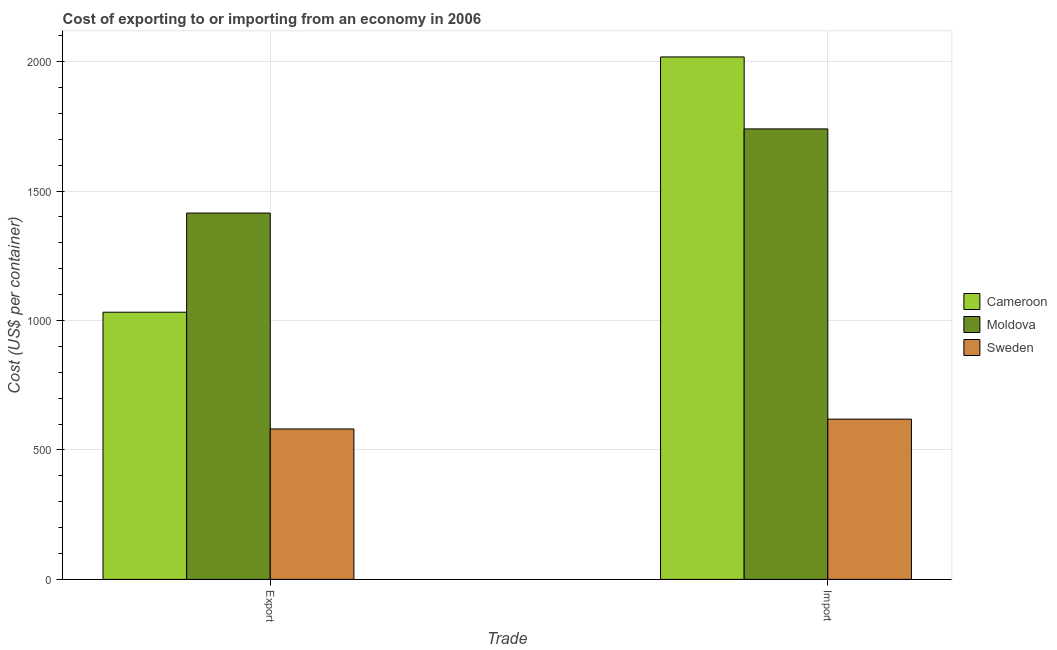How many groups of bars are there?
Offer a very short reply. 2. Are the number of bars on each tick of the X-axis equal?
Your answer should be very brief. Yes. How many bars are there on the 2nd tick from the right?
Your response must be concise. 3. What is the label of the 2nd group of bars from the left?
Provide a succinct answer. Import. What is the import cost in Sweden?
Make the answer very short. 619. Across all countries, what is the maximum import cost?
Make the answer very short. 2018. Across all countries, what is the minimum export cost?
Offer a very short reply. 581. In which country was the import cost maximum?
Keep it short and to the point. Cameroon. What is the total import cost in the graph?
Ensure brevity in your answer.  4377. What is the difference between the export cost in Cameroon and that in Moldova?
Ensure brevity in your answer.  -383. What is the difference between the import cost in Sweden and the export cost in Cameroon?
Offer a very short reply. -413. What is the average export cost per country?
Ensure brevity in your answer.  1009.33. What is the difference between the import cost and export cost in Sweden?
Your response must be concise. 38. In how many countries, is the export cost greater than 1800 US$?
Give a very brief answer. 0. What is the ratio of the import cost in Cameroon to that in Sweden?
Ensure brevity in your answer.  3.26. Is the import cost in Moldova less than that in Cameroon?
Give a very brief answer. Yes. In how many countries, is the import cost greater than the average import cost taken over all countries?
Offer a very short reply. 2. What does the 1st bar from the left in Export represents?
Provide a short and direct response. Cameroon. What does the 3rd bar from the right in Export represents?
Your answer should be very brief. Cameroon. How many bars are there?
Your answer should be very brief. 6. Are all the bars in the graph horizontal?
Your response must be concise. No. How many countries are there in the graph?
Keep it short and to the point. 3. What is the difference between two consecutive major ticks on the Y-axis?
Your answer should be very brief. 500. Does the graph contain grids?
Give a very brief answer. Yes. Where does the legend appear in the graph?
Give a very brief answer. Center right. How many legend labels are there?
Your response must be concise. 3. How are the legend labels stacked?
Ensure brevity in your answer.  Vertical. What is the title of the graph?
Offer a very short reply. Cost of exporting to or importing from an economy in 2006. What is the label or title of the X-axis?
Your response must be concise. Trade. What is the label or title of the Y-axis?
Provide a short and direct response. Cost (US$ per container). What is the Cost (US$ per container) in Cameroon in Export?
Make the answer very short. 1032. What is the Cost (US$ per container) in Moldova in Export?
Offer a very short reply. 1415. What is the Cost (US$ per container) of Sweden in Export?
Your answer should be compact. 581. What is the Cost (US$ per container) in Cameroon in Import?
Provide a short and direct response. 2018. What is the Cost (US$ per container) of Moldova in Import?
Your answer should be very brief. 1740. What is the Cost (US$ per container) of Sweden in Import?
Make the answer very short. 619. Across all Trade, what is the maximum Cost (US$ per container) in Cameroon?
Your response must be concise. 2018. Across all Trade, what is the maximum Cost (US$ per container) in Moldova?
Keep it short and to the point. 1740. Across all Trade, what is the maximum Cost (US$ per container) in Sweden?
Your answer should be very brief. 619. Across all Trade, what is the minimum Cost (US$ per container) in Cameroon?
Your answer should be very brief. 1032. Across all Trade, what is the minimum Cost (US$ per container) of Moldova?
Give a very brief answer. 1415. Across all Trade, what is the minimum Cost (US$ per container) in Sweden?
Offer a terse response. 581. What is the total Cost (US$ per container) of Cameroon in the graph?
Give a very brief answer. 3050. What is the total Cost (US$ per container) of Moldova in the graph?
Provide a succinct answer. 3155. What is the total Cost (US$ per container) of Sweden in the graph?
Offer a terse response. 1200. What is the difference between the Cost (US$ per container) of Cameroon in Export and that in Import?
Provide a succinct answer. -986. What is the difference between the Cost (US$ per container) of Moldova in Export and that in Import?
Your answer should be compact. -325. What is the difference between the Cost (US$ per container) in Sweden in Export and that in Import?
Your response must be concise. -38. What is the difference between the Cost (US$ per container) of Cameroon in Export and the Cost (US$ per container) of Moldova in Import?
Keep it short and to the point. -708. What is the difference between the Cost (US$ per container) of Cameroon in Export and the Cost (US$ per container) of Sweden in Import?
Your response must be concise. 413. What is the difference between the Cost (US$ per container) in Moldova in Export and the Cost (US$ per container) in Sweden in Import?
Your response must be concise. 796. What is the average Cost (US$ per container) in Cameroon per Trade?
Ensure brevity in your answer.  1525. What is the average Cost (US$ per container) in Moldova per Trade?
Your answer should be compact. 1577.5. What is the average Cost (US$ per container) in Sweden per Trade?
Your response must be concise. 600. What is the difference between the Cost (US$ per container) in Cameroon and Cost (US$ per container) in Moldova in Export?
Your answer should be compact. -383. What is the difference between the Cost (US$ per container) of Cameroon and Cost (US$ per container) of Sweden in Export?
Offer a very short reply. 451. What is the difference between the Cost (US$ per container) in Moldova and Cost (US$ per container) in Sweden in Export?
Offer a terse response. 834. What is the difference between the Cost (US$ per container) in Cameroon and Cost (US$ per container) in Moldova in Import?
Keep it short and to the point. 278. What is the difference between the Cost (US$ per container) of Cameroon and Cost (US$ per container) of Sweden in Import?
Your answer should be very brief. 1399. What is the difference between the Cost (US$ per container) in Moldova and Cost (US$ per container) in Sweden in Import?
Ensure brevity in your answer.  1121. What is the ratio of the Cost (US$ per container) of Cameroon in Export to that in Import?
Keep it short and to the point. 0.51. What is the ratio of the Cost (US$ per container) in Moldova in Export to that in Import?
Give a very brief answer. 0.81. What is the ratio of the Cost (US$ per container) of Sweden in Export to that in Import?
Keep it short and to the point. 0.94. What is the difference between the highest and the second highest Cost (US$ per container) of Cameroon?
Your answer should be compact. 986. What is the difference between the highest and the second highest Cost (US$ per container) in Moldova?
Your answer should be very brief. 325. What is the difference between the highest and the second highest Cost (US$ per container) of Sweden?
Your answer should be very brief. 38. What is the difference between the highest and the lowest Cost (US$ per container) of Cameroon?
Give a very brief answer. 986. What is the difference between the highest and the lowest Cost (US$ per container) in Moldova?
Offer a terse response. 325. What is the difference between the highest and the lowest Cost (US$ per container) in Sweden?
Your answer should be very brief. 38. 